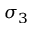<formula> <loc_0><loc_0><loc_500><loc_500>\sigma _ { 3 }</formula> 